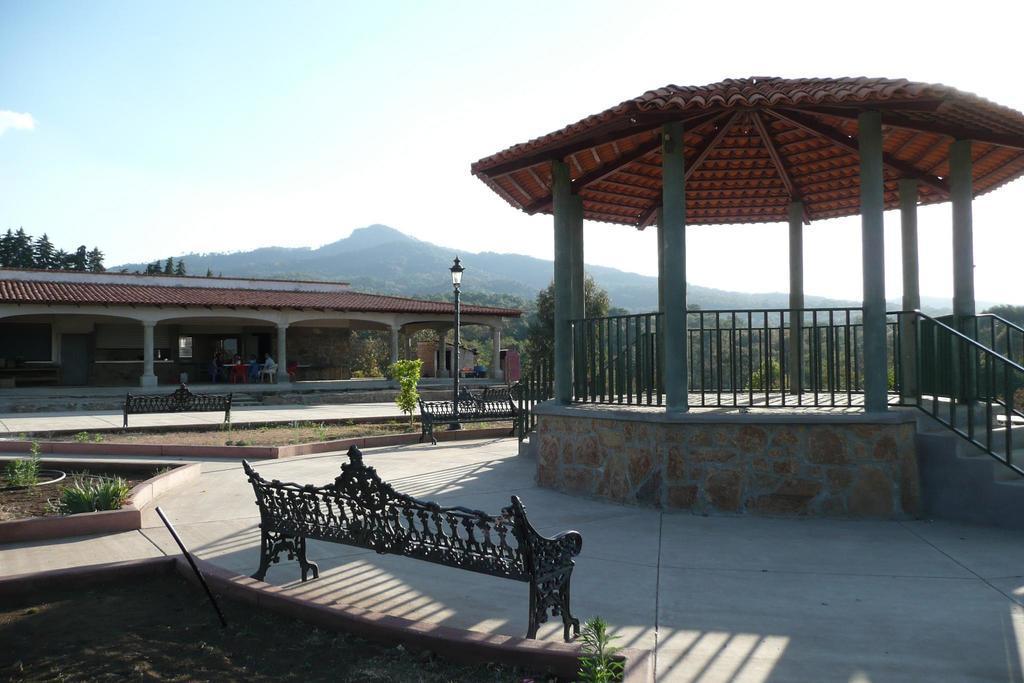In one or two sentences, can you explain what this image depicts? In this picture we can see benches, plants, light on pole, pillars, railing, wall and roof top. In the background of the image we can see houses, person, chairs, pillars, trees, hill and sky. 